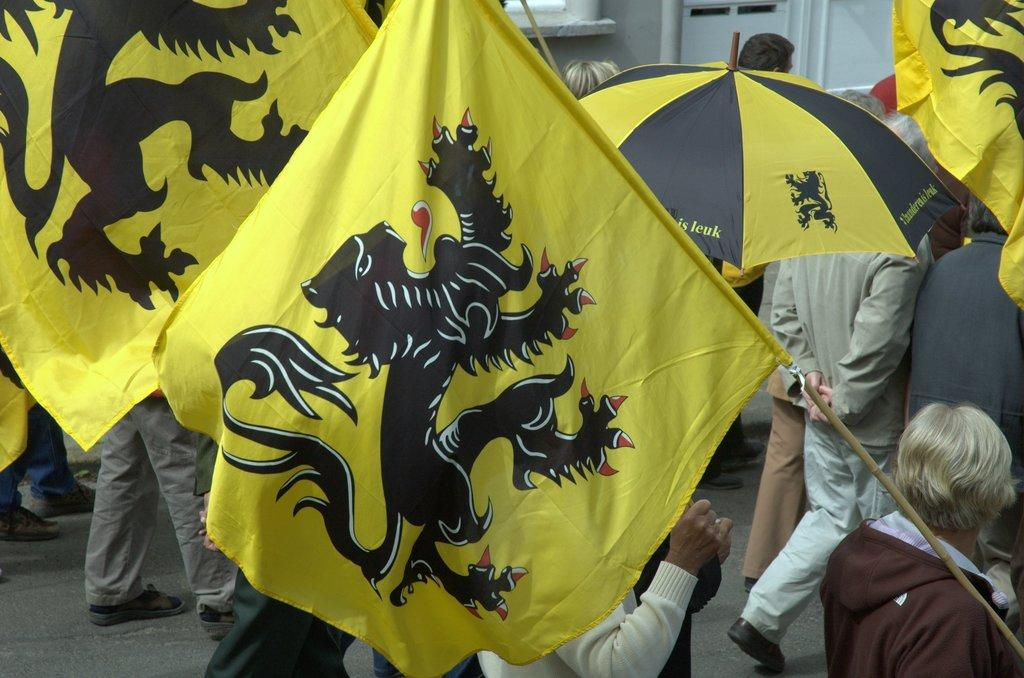Who is present in the image? There are people in the image. What are the people doing in the image? The people are walking on the road. Are there any objects being held by the people in the image? Yes, some people are holding flags and some are holding umbrellas. What type of trousers are the people wearing in the image? There is no information about the type of trousers the people are wearing in the image. Can you see any guns in the image? There are no guns present in the image. 